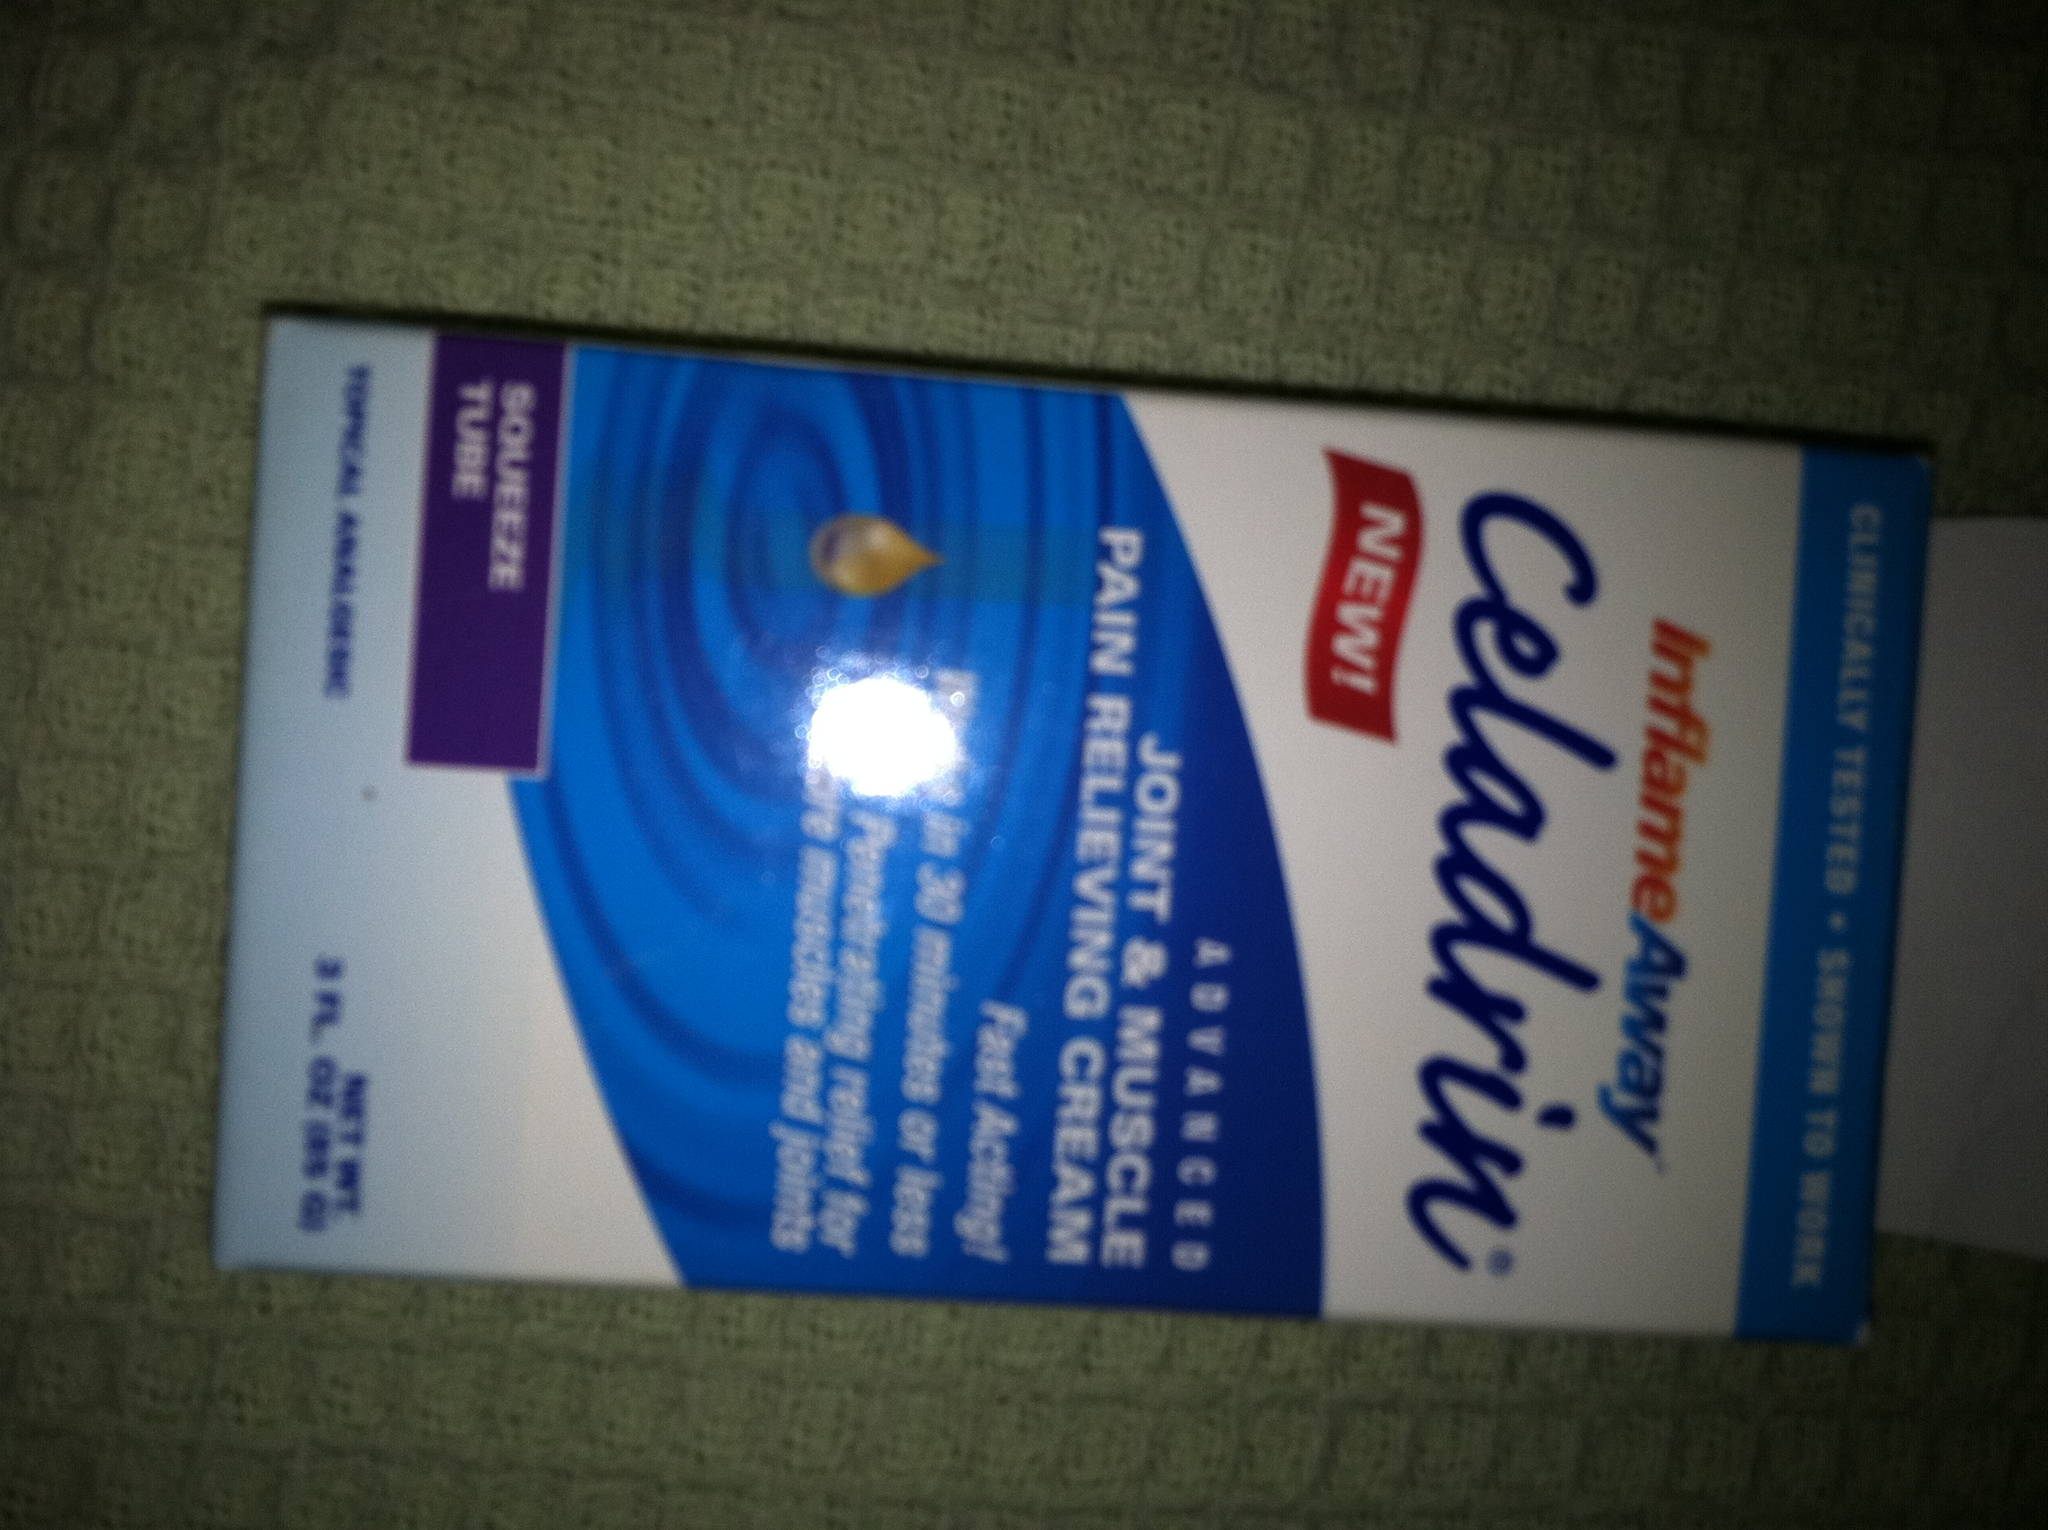Can you tell me more about how to use this product? Certainly! 'Capzasin' cream should be applied to the affected area up to 3 to 4 times daily. It's important to wash hands thoroughly after applying to avoid contact with eyes and other sensitive areas. It provides a warming sensation which can initially intensify before diminishing. 